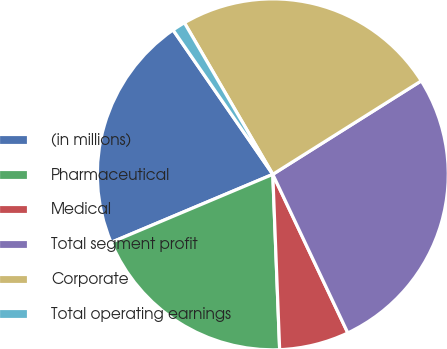Convert chart. <chart><loc_0><loc_0><loc_500><loc_500><pie_chart><fcel>(in millions)<fcel>Pharmaceutical<fcel>Medical<fcel>Total segment profit<fcel>Corporate<fcel>Total operating earnings<nl><fcel>21.72%<fcel>19.28%<fcel>6.41%<fcel>26.91%<fcel>24.46%<fcel>1.22%<nl></chart> 